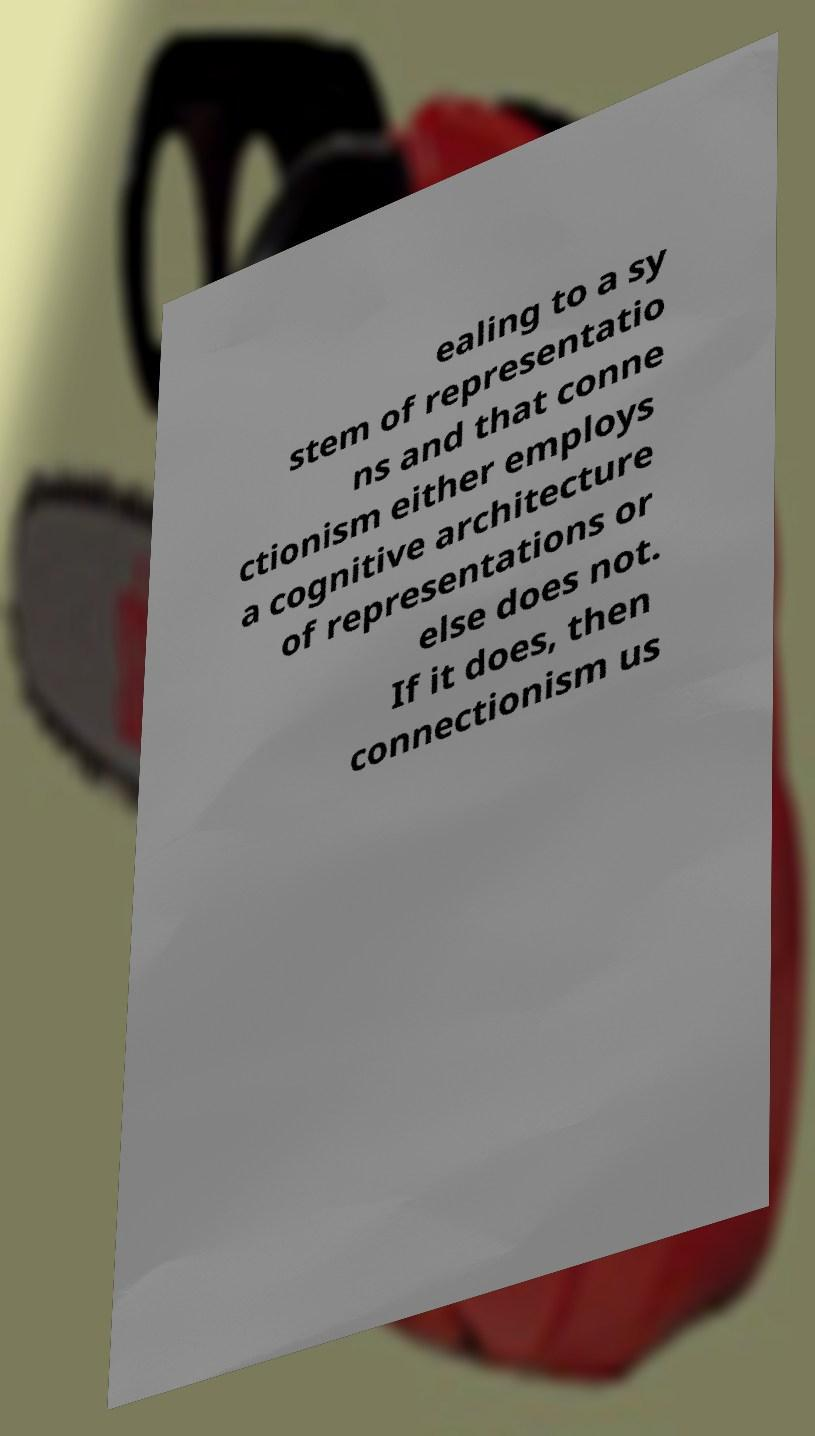There's text embedded in this image that I need extracted. Can you transcribe it verbatim? ealing to a sy stem of representatio ns and that conne ctionism either employs a cognitive architecture of representations or else does not. If it does, then connectionism us 